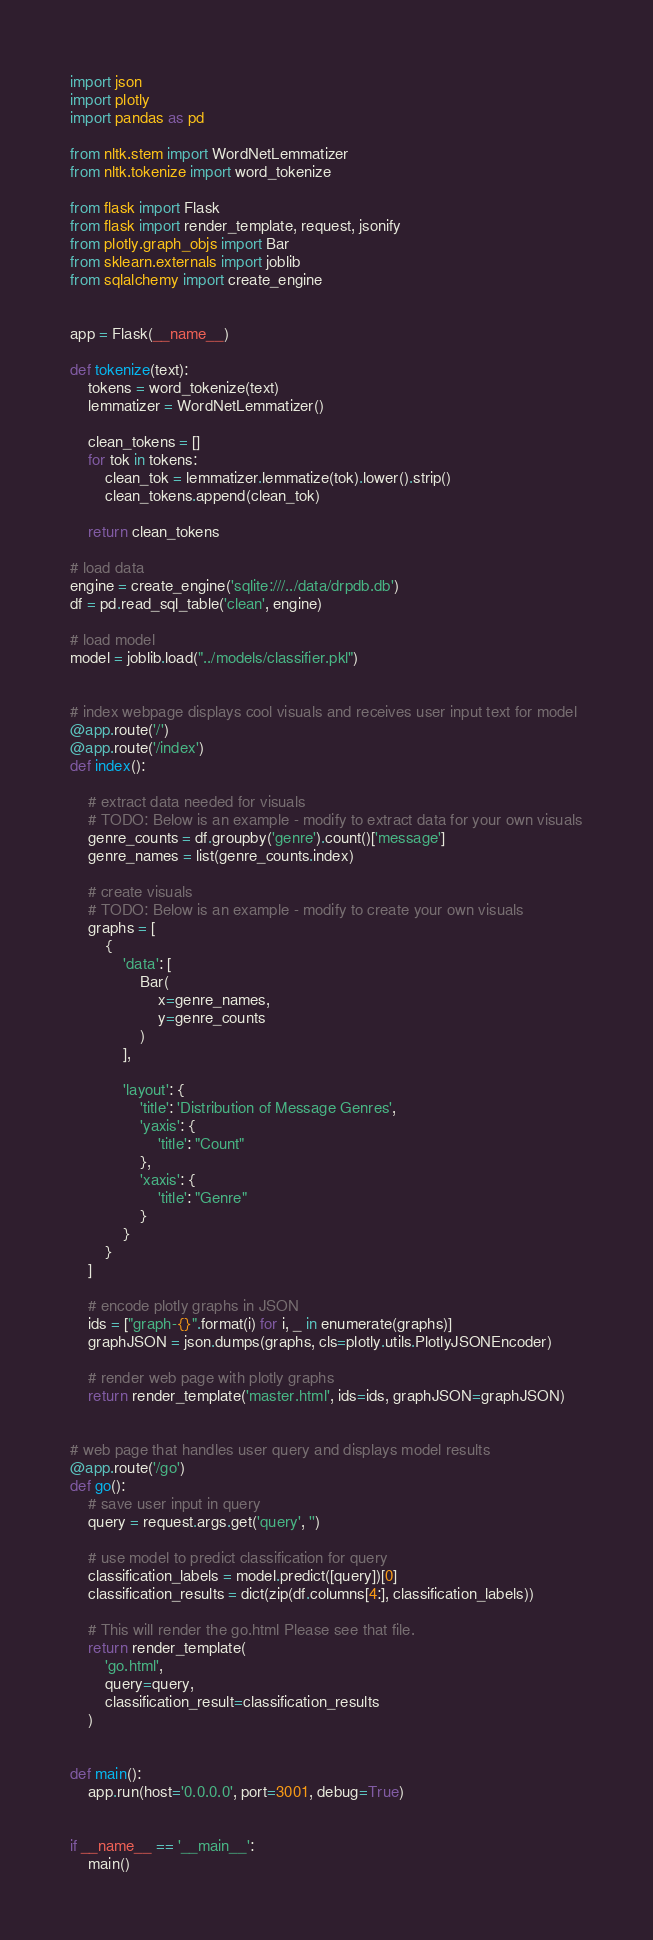<code> <loc_0><loc_0><loc_500><loc_500><_Python_>import json
import plotly
import pandas as pd

from nltk.stem import WordNetLemmatizer
from nltk.tokenize import word_tokenize

from flask import Flask
from flask import render_template, request, jsonify
from plotly.graph_objs import Bar
from sklearn.externals import joblib
from sqlalchemy import create_engine


app = Flask(__name__)

def tokenize(text):
    tokens = word_tokenize(text)
    lemmatizer = WordNetLemmatizer()

    clean_tokens = []
    for tok in tokens:
        clean_tok = lemmatizer.lemmatize(tok).lower().strip()
        clean_tokens.append(clean_tok)

    return clean_tokens

# load data
engine = create_engine('sqlite:///../data/drpdb.db')
df = pd.read_sql_table('clean', engine)

# load model
model = joblib.load("../models/classifier.pkl")


# index webpage displays cool visuals and receives user input text for model
@app.route('/')
@app.route('/index')
def index():
    
    # extract data needed for visuals
    # TODO: Below is an example - modify to extract data for your own visuals
    genre_counts = df.groupby('genre').count()['message']
    genre_names = list(genre_counts.index)
    
    # create visuals
    # TODO: Below is an example - modify to create your own visuals
    graphs = [
        {
            'data': [
                Bar(
                    x=genre_names,
                    y=genre_counts
                )
            ],

            'layout': {
                'title': 'Distribution of Message Genres',
                'yaxis': {
                    'title': "Count"
                },
                'xaxis': {
                    'title': "Genre"
                }
            }
        }
    ]
    
    # encode plotly graphs in JSON
    ids = ["graph-{}".format(i) for i, _ in enumerate(graphs)]
    graphJSON = json.dumps(graphs, cls=plotly.utils.PlotlyJSONEncoder)
    
    # render web page with plotly graphs
    return render_template('master.html', ids=ids, graphJSON=graphJSON)


# web page that handles user query and displays model results
@app.route('/go')
def go():
    # save user input in query
    query = request.args.get('query', '') 

    # use model to predict classification for query
    classification_labels = model.predict([query])[0]
    classification_results = dict(zip(df.columns[4:], classification_labels))

    # This will render the go.html Please see that file. 
    return render_template(
        'go.html',
        query=query,
        classification_result=classification_results
    )


def main():
    app.run(host='0.0.0.0', port=3001, debug=True)


if __name__ == '__main__':
    main()</code> 